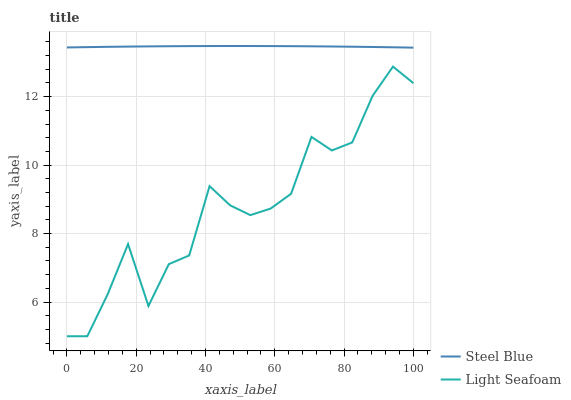Does Light Seafoam have the minimum area under the curve?
Answer yes or no. Yes. Does Steel Blue have the maximum area under the curve?
Answer yes or no. Yes. Does Steel Blue have the minimum area under the curve?
Answer yes or no. No. Is Steel Blue the smoothest?
Answer yes or no. Yes. Is Light Seafoam the roughest?
Answer yes or no. Yes. Is Steel Blue the roughest?
Answer yes or no. No. Does Light Seafoam have the lowest value?
Answer yes or no. Yes. Does Steel Blue have the lowest value?
Answer yes or no. No. Does Steel Blue have the highest value?
Answer yes or no. Yes. Is Light Seafoam less than Steel Blue?
Answer yes or no. Yes. Is Steel Blue greater than Light Seafoam?
Answer yes or no. Yes. Does Light Seafoam intersect Steel Blue?
Answer yes or no. No. 